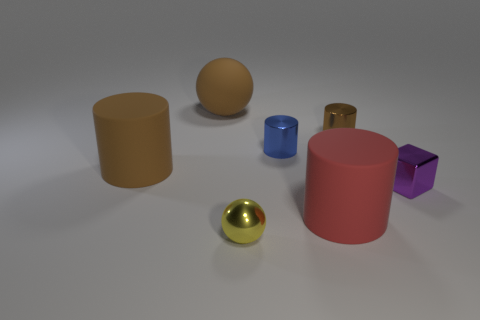Is there a small block that has the same material as the tiny brown cylinder?
Keep it short and to the point. Yes. There is another big thing that is the same shape as the red matte thing; what is its color?
Your response must be concise. Brown. Is the number of tiny spheres that are behind the purple cube less than the number of tiny metallic cylinders that are behind the large brown cylinder?
Your answer should be compact. Yes. How many other things are there of the same shape as the small blue metal thing?
Offer a very short reply. 3. Is the number of tiny brown objects that are left of the small yellow object less than the number of big brown balls?
Ensure brevity in your answer.  Yes. What is the object that is to the right of the small brown metal thing made of?
Your answer should be very brief. Metal. What number of other objects are the same size as the purple metallic thing?
Offer a terse response. 3. Are there fewer blue shiny cylinders than rubber things?
Provide a succinct answer. Yes. The small blue shiny object has what shape?
Your answer should be compact. Cylinder. There is a ball that is in front of the purple shiny thing; does it have the same color as the metal cube?
Provide a short and direct response. No. 